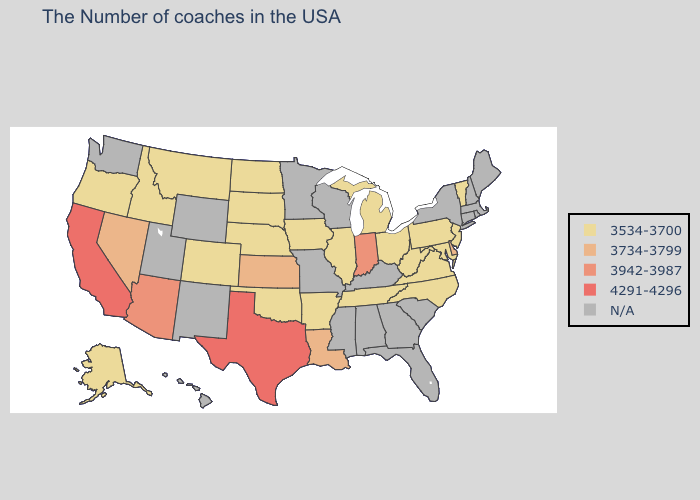Does the first symbol in the legend represent the smallest category?
Give a very brief answer. Yes. Which states have the lowest value in the USA?
Keep it brief. Vermont, New Jersey, Maryland, Pennsylvania, Virginia, North Carolina, West Virginia, Ohio, Michigan, Tennessee, Illinois, Arkansas, Iowa, Nebraska, Oklahoma, South Dakota, North Dakota, Colorado, Montana, Idaho, Oregon, Alaska. Does Nebraska have the highest value in the USA?
Quick response, please. No. What is the lowest value in the Northeast?
Write a very short answer. 3534-3700. What is the value of Arkansas?
Be succinct. 3534-3700. Name the states that have a value in the range N/A?
Give a very brief answer. Maine, Massachusetts, Rhode Island, New Hampshire, Connecticut, New York, South Carolina, Florida, Georgia, Kentucky, Alabama, Wisconsin, Mississippi, Missouri, Minnesota, Wyoming, New Mexico, Utah, Washington, Hawaii. How many symbols are there in the legend?
Concise answer only. 5. What is the value of West Virginia?
Be succinct. 3534-3700. What is the lowest value in states that border Montana?
Keep it brief. 3534-3700. Name the states that have a value in the range 4291-4296?
Keep it brief. Texas, California. Which states have the highest value in the USA?
Short answer required. Texas, California. What is the value of New Jersey?
Give a very brief answer. 3534-3700. 